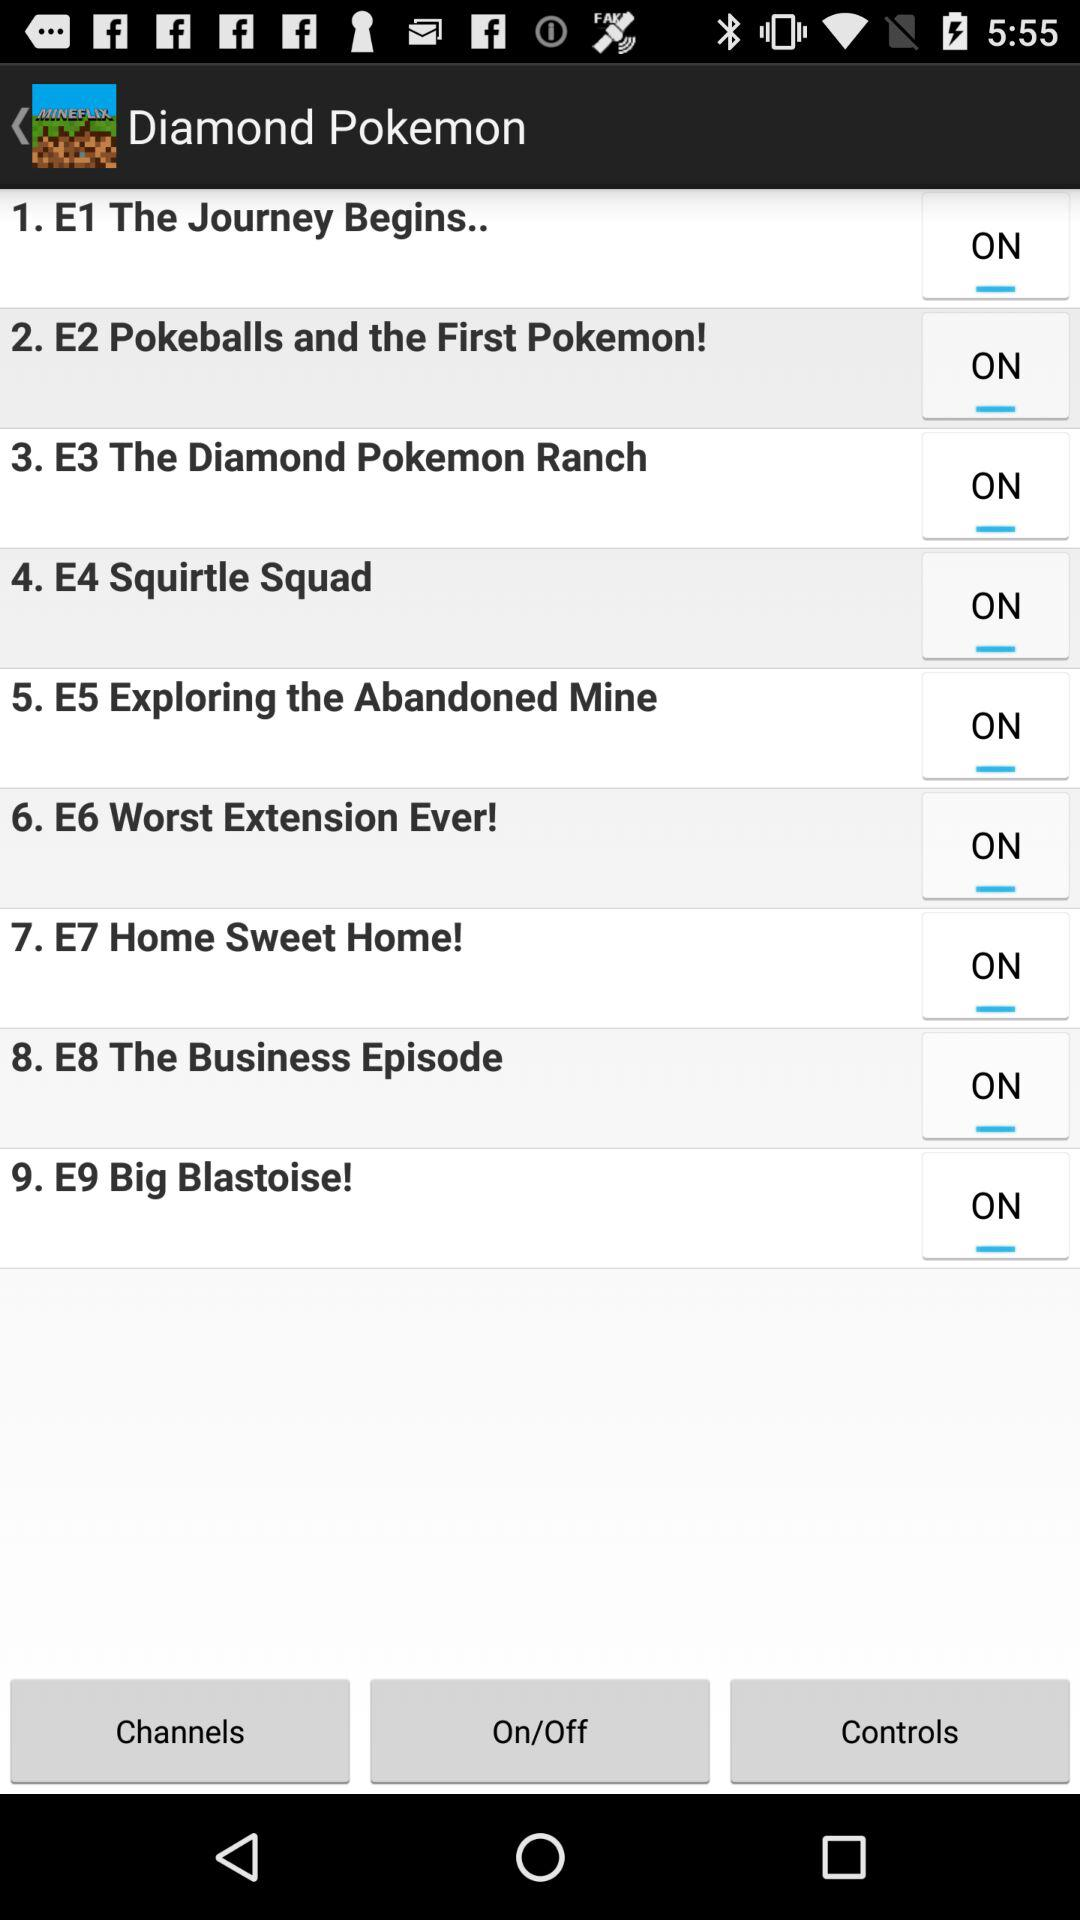Which episode number is "The Journey Begins.."? "The Journey Begins.." is the first episode. 